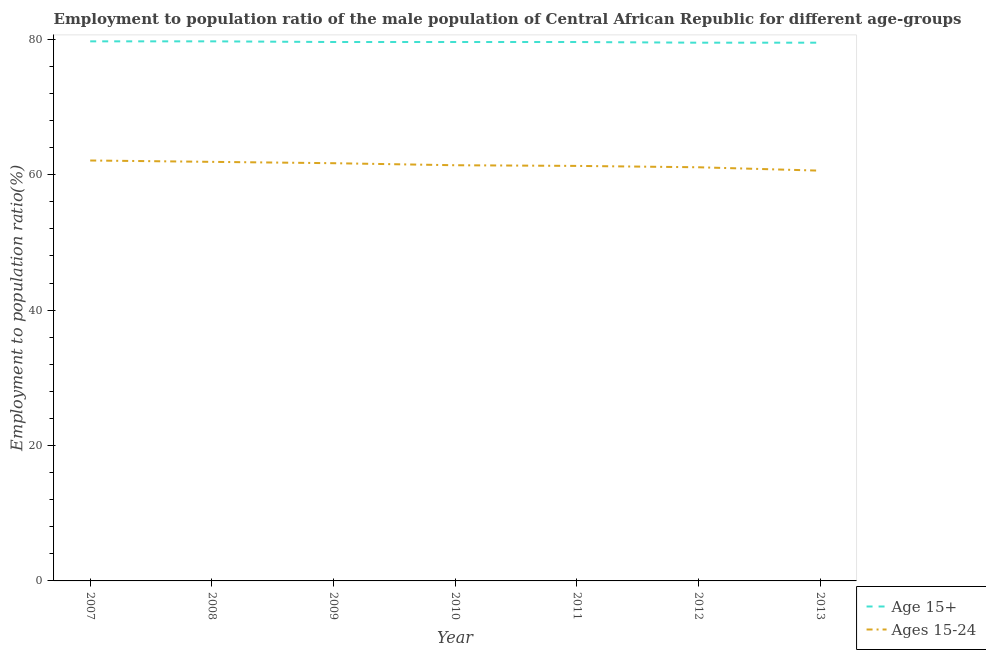Does the line corresponding to employment to population ratio(age 15-24) intersect with the line corresponding to employment to population ratio(age 15+)?
Give a very brief answer. No. What is the employment to population ratio(age 15+) in 2008?
Your answer should be very brief. 79.7. Across all years, what is the maximum employment to population ratio(age 15+)?
Provide a succinct answer. 79.7. Across all years, what is the minimum employment to population ratio(age 15-24)?
Provide a succinct answer. 60.6. In which year was the employment to population ratio(age 15-24) maximum?
Provide a short and direct response. 2007. What is the total employment to population ratio(age 15-24) in the graph?
Provide a short and direct response. 430.1. What is the difference between the employment to population ratio(age 15+) in 2011 and the employment to population ratio(age 15-24) in 2010?
Provide a short and direct response. 18.2. What is the average employment to population ratio(age 15-24) per year?
Your answer should be very brief. 61.44. In the year 2007, what is the difference between the employment to population ratio(age 15+) and employment to population ratio(age 15-24)?
Your answer should be very brief. 17.6. What is the ratio of the employment to population ratio(age 15+) in 2007 to that in 2011?
Keep it short and to the point. 1. Is the employment to population ratio(age 15+) in 2008 less than that in 2009?
Offer a very short reply. No. What is the difference between the highest and the lowest employment to population ratio(age 15+)?
Offer a terse response. 0.2. In how many years, is the employment to population ratio(age 15+) greater than the average employment to population ratio(age 15+) taken over all years?
Keep it short and to the point. 2. Is the sum of the employment to population ratio(age 15-24) in 2008 and 2011 greater than the maximum employment to population ratio(age 15+) across all years?
Offer a very short reply. Yes. Is the employment to population ratio(age 15-24) strictly less than the employment to population ratio(age 15+) over the years?
Make the answer very short. Yes. How many years are there in the graph?
Offer a very short reply. 7. Are the values on the major ticks of Y-axis written in scientific E-notation?
Provide a succinct answer. No. Does the graph contain grids?
Offer a terse response. No. Where does the legend appear in the graph?
Make the answer very short. Bottom right. What is the title of the graph?
Ensure brevity in your answer.  Employment to population ratio of the male population of Central African Republic for different age-groups. Does "Highest 20% of population" appear as one of the legend labels in the graph?
Your answer should be compact. No. What is the label or title of the X-axis?
Keep it short and to the point. Year. What is the label or title of the Y-axis?
Give a very brief answer. Employment to population ratio(%). What is the Employment to population ratio(%) of Age 15+ in 2007?
Make the answer very short. 79.7. What is the Employment to population ratio(%) in Ages 15-24 in 2007?
Offer a terse response. 62.1. What is the Employment to population ratio(%) in Age 15+ in 2008?
Provide a succinct answer. 79.7. What is the Employment to population ratio(%) of Ages 15-24 in 2008?
Offer a very short reply. 61.9. What is the Employment to population ratio(%) in Age 15+ in 2009?
Your response must be concise. 79.6. What is the Employment to population ratio(%) in Ages 15-24 in 2009?
Provide a succinct answer. 61.7. What is the Employment to population ratio(%) of Age 15+ in 2010?
Ensure brevity in your answer.  79.6. What is the Employment to population ratio(%) in Ages 15-24 in 2010?
Offer a terse response. 61.4. What is the Employment to population ratio(%) in Age 15+ in 2011?
Ensure brevity in your answer.  79.6. What is the Employment to population ratio(%) of Ages 15-24 in 2011?
Ensure brevity in your answer.  61.3. What is the Employment to population ratio(%) of Age 15+ in 2012?
Give a very brief answer. 79.5. What is the Employment to population ratio(%) of Ages 15-24 in 2012?
Ensure brevity in your answer.  61.1. What is the Employment to population ratio(%) of Age 15+ in 2013?
Offer a very short reply. 79.5. What is the Employment to population ratio(%) of Ages 15-24 in 2013?
Provide a succinct answer. 60.6. Across all years, what is the maximum Employment to population ratio(%) in Age 15+?
Offer a very short reply. 79.7. Across all years, what is the maximum Employment to population ratio(%) in Ages 15-24?
Give a very brief answer. 62.1. Across all years, what is the minimum Employment to population ratio(%) of Age 15+?
Provide a short and direct response. 79.5. Across all years, what is the minimum Employment to population ratio(%) in Ages 15-24?
Your response must be concise. 60.6. What is the total Employment to population ratio(%) of Age 15+ in the graph?
Make the answer very short. 557.2. What is the total Employment to population ratio(%) in Ages 15-24 in the graph?
Keep it short and to the point. 430.1. What is the difference between the Employment to population ratio(%) in Age 15+ in 2007 and that in 2008?
Your response must be concise. 0. What is the difference between the Employment to population ratio(%) in Ages 15-24 in 2007 and that in 2009?
Your response must be concise. 0.4. What is the difference between the Employment to population ratio(%) in Ages 15-24 in 2007 and that in 2010?
Make the answer very short. 0.7. What is the difference between the Employment to population ratio(%) of Ages 15-24 in 2007 and that in 2011?
Keep it short and to the point. 0.8. What is the difference between the Employment to population ratio(%) in Ages 15-24 in 2007 and that in 2012?
Offer a very short reply. 1. What is the difference between the Employment to population ratio(%) of Age 15+ in 2007 and that in 2013?
Your answer should be very brief. 0.2. What is the difference between the Employment to population ratio(%) of Ages 15-24 in 2007 and that in 2013?
Ensure brevity in your answer.  1.5. What is the difference between the Employment to population ratio(%) in Age 15+ in 2008 and that in 2010?
Offer a very short reply. 0.1. What is the difference between the Employment to population ratio(%) in Age 15+ in 2008 and that in 2011?
Ensure brevity in your answer.  0.1. What is the difference between the Employment to population ratio(%) of Age 15+ in 2008 and that in 2012?
Your answer should be very brief. 0.2. What is the difference between the Employment to population ratio(%) in Ages 15-24 in 2008 and that in 2013?
Keep it short and to the point. 1.3. What is the difference between the Employment to population ratio(%) of Age 15+ in 2009 and that in 2010?
Provide a short and direct response. 0. What is the difference between the Employment to population ratio(%) of Ages 15-24 in 2009 and that in 2011?
Your answer should be compact. 0.4. What is the difference between the Employment to population ratio(%) in Age 15+ in 2009 and that in 2012?
Your answer should be very brief. 0.1. What is the difference between the Employment to population ratio(%) of Ages 15-24 in 2009 and that in 2012?
Provide a succinct answer. 0.6. What is the difference between the Employment to population ratio(%) of Age 15+ in 2009 and that in 2013?
Provide a short and direct response. 0.1. What is the difference between the Employment to population ratio(%) of Ages 15-24 in 2009 and that in 2013?
Ensure brevity in your answer.  1.1. What is the difference between the Employment to population ratio(%) of Age 15+ in 2010 and that in 2011?
Offer a terse response. 0. What is the difference between the Employment to population ratio(%) in Ages 15-24 in 2010 and that in 2011?
Offer a very short reply. 0.1. What is the difference between the Employment to population ratio(%) of Age 15+ in 2011 and that in 2012?
Keep it short and to the point. 0.1. What is the difference between the Employment to population ratio(%) in Ages 15-24 in 2011 and that in 2012?
Your answer should be compact. 0.2. What is the difference between the Employment to population ratio(%) of Age 15+ in 2011 and that in 2013?
Ensure brevity in your answer.  0.1. What is the difference between the Employment to population ratio(%) of Ages 15-24 in 2011 and that in 2013?
Give a very brief answer. 0.7. What is the difference between the Employment to population ratio(%) of Ages 15-24 in 2012 and that in 2013?
Provide a succinct answer. 0.5. What is the difference between the Employment to population ratio(%) in Age 15+ in 2007 and the Employment to population ratio(%) in Ages 15-24 in 2008?
Provide a short and direct response. 17.8. What is the difference between the Employment to population ratio(%) of Age 15+ in 2007 and the Employment to population ratio(%) of Ages 15-24 in 2011?
Provide a succinct answer. 18.4. What is the difference between the Employment to population ratio(%) of Age 15+ in 2007 and the Employment to population ratio(%) of Ages 15-24 in 2012?
Give a very brief answer. 18.6. What is the difference between the Employment to population ratio(%) of Age 15+ in 2008 and the Employment to population ratio(%) of Ages 15-24 in 2010?
Offer a very short reply. 18.3. What is the difference between the Employment to population ratio(%) in Age 15+ in 2008 and the Employment to population ratio(%) in Ages 15-24 in 2011?
Give a very brief answer. 18.4. What is the difference between the Employment to population ratio(%) in Age 15+ in 2008 and the Employment to population ratio(%) in Ages 15-24 in 2012?
Make the answer very short. 18.6. What is the difference between the Employment to population ratio(%) of Age 15+ in 2009 and the Employment to population ratio(%) of Ages 15-24 in 2010?
Offer a terse response. 18.2. What is the difference between the Employment to population ratio(%) of Age 15+ in 2009 and the Employment to population ratio(%) of Ages 15-24 in 2012?
Offer a very short reply. 18.5. What is the difference between the Employment to population ratio(%) in Age 15+ in 2009 and the Employment to population ratio(%) in Ages 15-24 in 2013?
Provide a succinct answer. 19. What is the difference between the Employment to population ratio(%) of Age 15+ in 2011 and the Employment to population ratio(%) of Ages 15-24 in 2012?
Offer a very short reply. 18.5. What is the average Employment to population ratio(%) of Age 15+ per year?
Give a very brief answer. 79.6. What is the average Employment to population ratio(%) in Ages 15-24 per year?
Provide a short and direct response. 61.44. In the year 2007, what is the difference between the Employment to population ratio(%) in Age 15+ and Employment to population ratio(%) in Ages 15-24?
Make the answer very short. 17.6. In the year 2009, what is the difference between the Employment to population ratio(%) of Age 15+ and Employment to population ratio(%) of Ages 15-24?
Your answer should be very brief. 17.9. In the year 2012, what is the difference between the Employment to population ratio(%) of Age 15+ and Employment to population ratio(%) of Ages 15-24?
Give a very brief answer. 18.4. In the year 2013, what is the difference between the Employment to population ratio(%) of Age 15+ and Employment to population ratio(%) of Ages 15-24?
Ensure brevity in your answer.  18.9. What is the ratio of the Employment to population ratio(%) in Ages 15-24 in 2007 to that in 2008?
Offer a terse response. 1. What is the ratio of the Employment to population ratio(%) in Ages 15-24 in 2007 to that in 2010?
Your answer should be very brief. 1.01. What is the ratio of the Employment to population ratio(%) in Age 15+ in 2007 to that in 2011?
Your answer should be compact. 1. What is the ratio of the Employment to population ratio(%) in Ages 15-24 in 2007 to that in 2011?
Make the answer very short. 1.01. What is the ratio of the Employment to population ratio(%) of Ages 15-24 in 2007 to that in 2012?
Offer a terse response. 1.02. What is the ratio of the Employment to population ratio(%) of Age 15+ in 2007 to that in 2013?
Make the answer very short. 1. What is the ratio of the Employment to population ratio(%) in Ages 15-24 in 2007 to that in 2013?
Make the answer very short. 1.02. What is the ratio of the Employment to population ratio(%) in Age 15+ in 2008 to that in 2009?
Make the answer very short. 1. What is the ratio of the Employment to population ratio(%) in Ages 15-24 in 2008 to that in 2009?
Provide a short and direct response. 1. What is the ratio of the Employment to population ratio(%) of Age 15+ in 2008 to that in 2010?
Provide a short and direct response. 1. What is the ratio of the Employment to population ratio(%) in Ages 15-24 in 2008 to that in 2011?
Your answer should be very brief. 1.01. What is the ratio of the Employment to population ratio(%) of Ages 15-24 in 2008 to that in 2012?
Your answer should be very brief. 1.01. What is the ratio of the Employment to population ratio(%) in Age 15+ in 2008 to that in 2013?
Give a very brief answer. 1. What is the ratio of the Employment to population ratio(%) of Ages 15-24 in 2008 to that in 2013?
Your answer should be very brief. 1.02. What is the ratio of the Employment to population ratio(%) in Age 15+ in 2009 to that in 2010?
Ensure brevity in your answer.  1. What is the ratio of the Employment to population ratio(%) in Ages 15-24 in 2009 to that in 2011?
Provide a succinct answer. 1.01. What is the ratio of the Employment to population ratio(%) of Ages 15-24 in 2009 to that in 2012?
Keep it short and to the point. 1.01. What is the ratio of the Employment to population ratio(%) in Age 15+ in 2009 to that in 2013?
Offer a terse response. 1. What is the ratio of the Employment to population ratio(%) in Ages 15-24 in 2009 to that in 2013?
Provide a succinct answer. 1.02. What is the ratio of the Employment to population ratio(%) in Ages 15-24 in 2010 to that in 2011?
Give a very brief answer. 1. What is the ratio of the Employment to population ratio(%) in Age 15+ in 2010 to that in 2012?
Your answer should be very brief. 1. What is the ratio of the Employment to population ratio(%) in Ages 15-24 in 2010 to that in 2012?
Provide a succinct answer. 1. What is the ratio of the Employment to population ratio(%) of Age 15+ in 2010 to that in 2013?
Offer a terse response. 1. What is the ratio of the Employment to population ratio(%) in Ages 15-24 in 2010 to that in 2013?
Your response must be concise. 1.01. What is the ratio of the Employment to population ratio(%) of Age 15+ in 2011 to that in 2012?
Offer a very short reply. 1. What is the ratio of the Employment to population ratio(%) in Age 15+ in 2011 to that in 2013?
Provide a succinct answer. 1. What is the ratio of the Employment to population ratio(%) of Ages 15-24 in 2011 to that in 2013?
Your answer should be compact. 1.01. What is the ratio of the Employment to population ratio(%) of Age 15+ in 2012 to that in 2013?
Offer a very short reply. 1. What is the ratio of the Employment to population ratio(%) in Ages 15-24 in 2012 to that in 2013?
Give a very brief answer. 1.01. What is the difference between the highest and the second highest Employment to population ratio(%) in Ages 15-24?
Your answer should be compact. 0.2. 